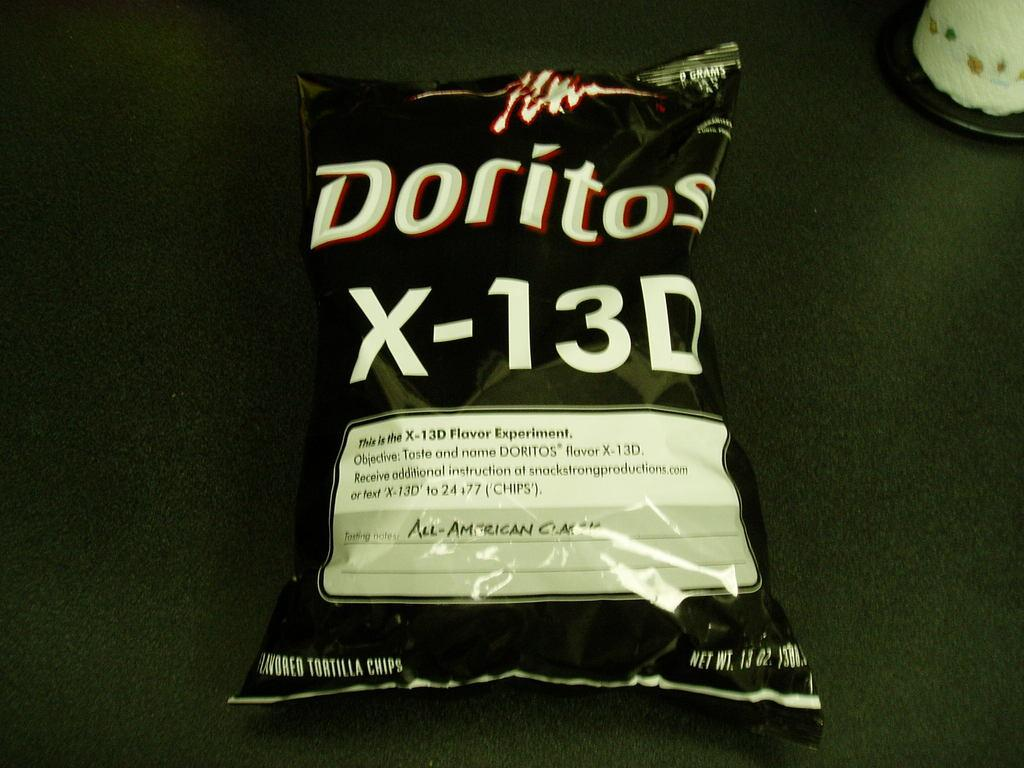Provide a one-sentence caption for the provided image. An experimental bag of Doritos labeled x-13D is unopened. 